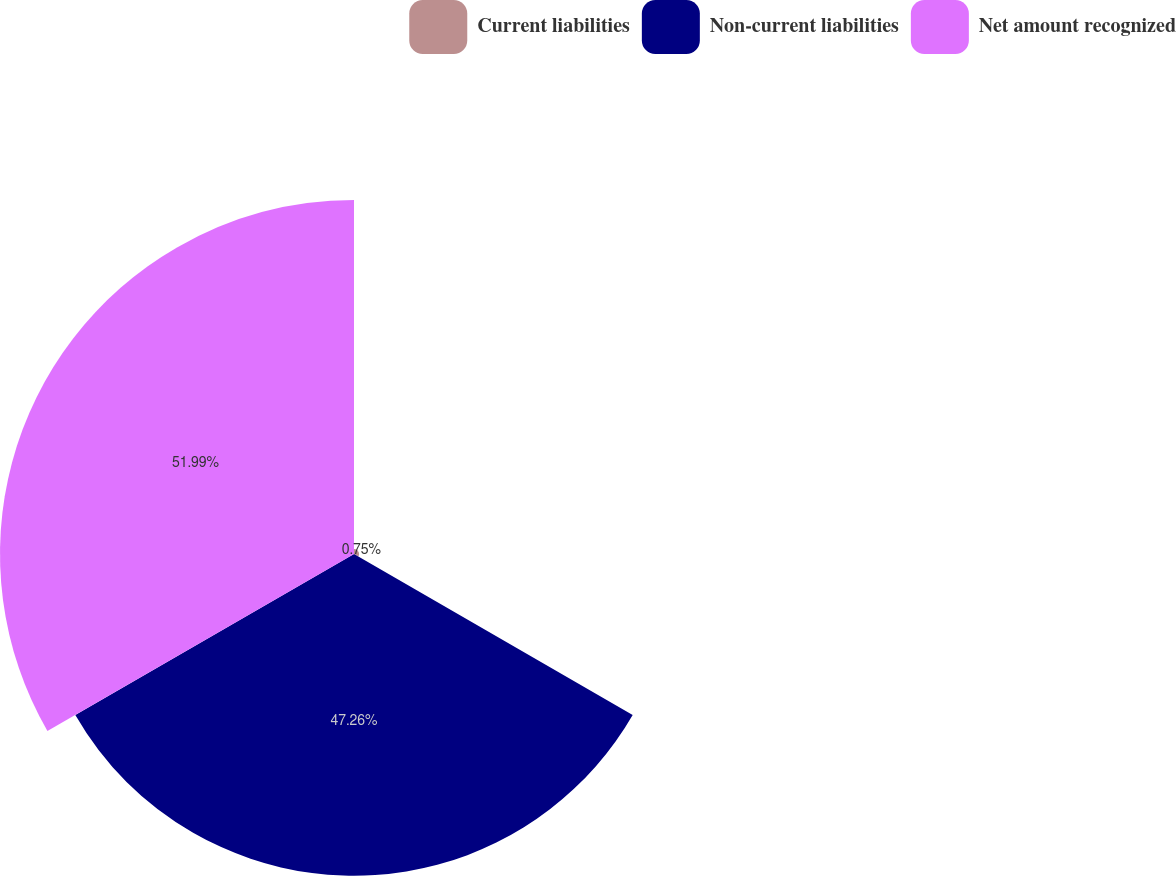<chart> <loc_0><loc_0><loc_500><loc_500><pie_chart><fcel>Current liabilities<fcel>Non-current liabilities<fcel>Net amount recognized<nl><fcel>0.75%<fcel>47.26%<fcel>51.99%<nl></chart> 